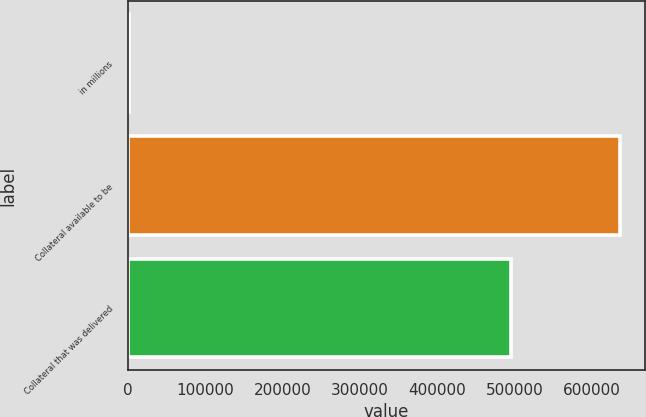Convert chart to OTSL. <chart><loc_0><loc_0><loc_500><loc_500><bar_chart><fcel>in millions<fcel>Collateral available to be<fcel>Collateral that was delivered<nl><fcel>2015<fcel>636684<fcel>496240<nl></chart> 